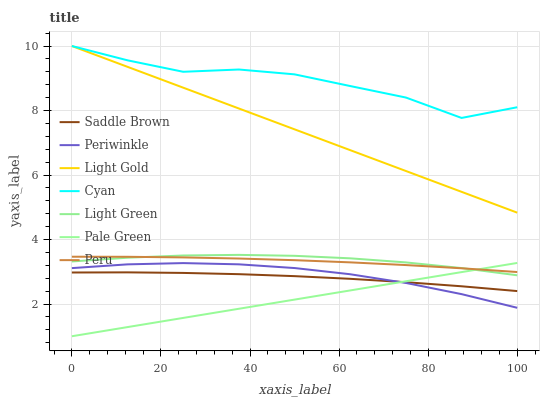Does Pale Green have the minimum area under the curve?
Answer yes or no. Yes. Does Cyan have the maximum area under the curve?
Answer yes or no. Yes. Does Periwinkle have the minimum area under the curve?
Answer yes or no. No. Does Periwinkle have the maximum area under the curve?
Answer yes or no. No. Is Pale Green the smoothest?
Answer yes or no. Yes. Is Cyan the roughest?
Answer yes or no. Yes. Is Periwinkle the smoothest?
Answer yes or no. No. Is Periwinkle the roughest?
Answer yes or no. No. Does Pale Green have the lowest value?
Answer yes or no. Yes. Does Periwinkle have the lowest value?
Answer yes or no. No. Does Light Gold have the highest value?
Answer yes or no. Yes. Does Pale Green have the highest value?
Answer yes or no. No. Is Saddle Brown less than Light Green?
Answer yes or no. Yes. Is Light Gold greater than Saddle Brown?
Answer yes or no. Yes. Does Saddle Brown intersect Periwinkle?
Answer yes or no. Yes. Is Saddle Brown less than Periwinkle?
Answer yes or no. No. Is Saddle Brown greater than Periwinkle?
Answer yes or no. No. Does Saddle Brown intersect Light Green?
Answer yes or no. No. 